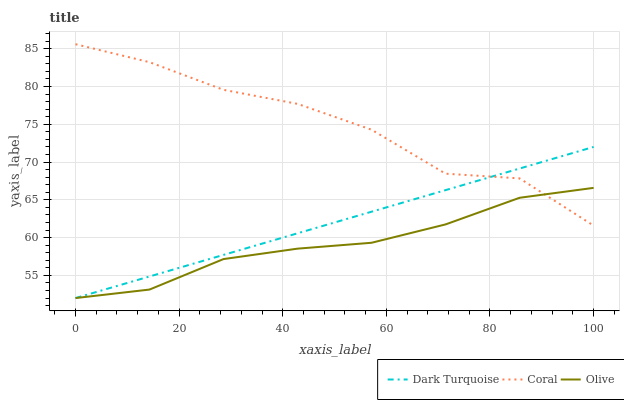Does Olive have the minimum area under the curve?
Answer yes or no. Yes. Does Coral have the maximum area under the curve?
Answer yes or no. Yes. Does Dark Turquoise have the minimum area under the curve?
Answer yes or no. No. Does Dark Turquoise have the maximum area under the curve?
Answer yes or no. No. Is Dark Turquoise the smoothest?
Answer yes or no. Yes. Is Coral the roughest?
Answer yes or no. Yes. Is Coral the smoothest?
Answer yes or no. No. Is Dark Turquoise the roughest?
Answer yes or no. No. Does Coral have the lowest value?
Answer yes or no. No. Does Coral have the highest value?
Answer yes or no. Yes. Does Dark Turquoise have the highest value?
Answer yes or no. No. Does Coral intersect Dark Turquoise?
Answer yes or no. Yes. Is Coral less than Dark Turquoise?
Answer yes or no. No. Is Coral greater than Dark Turquoise?
Answer yes or no. No. 